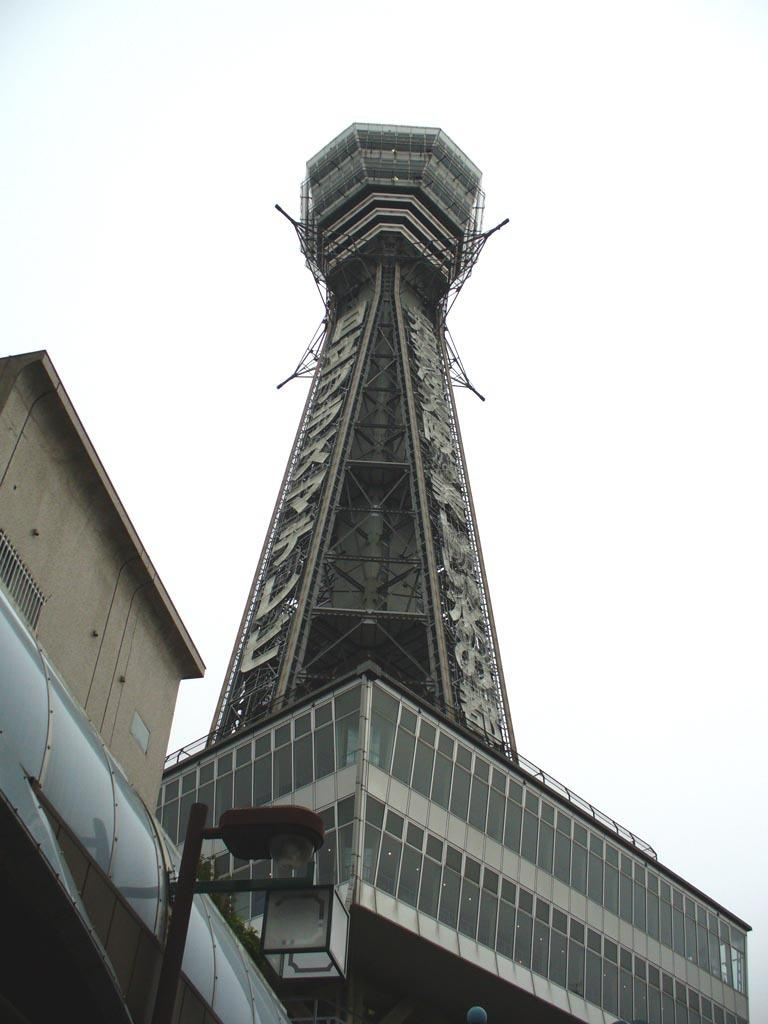What type of material is used for the building in the image? The building in the image has glass. What feature can be seen on the building? There is a tower on the building. What is located on top of the tower? The tower has a building on top of it. How many floors does the building on top of the tower have? The building on top of the tower has multiple floors. What is visible behind the building and tower? The sky is visible behind the building and tower. What type of leather is used to make the dogs' collars in the image? There are no dogs or collars present in the image; it features a building with a tower and a building on top of it. 